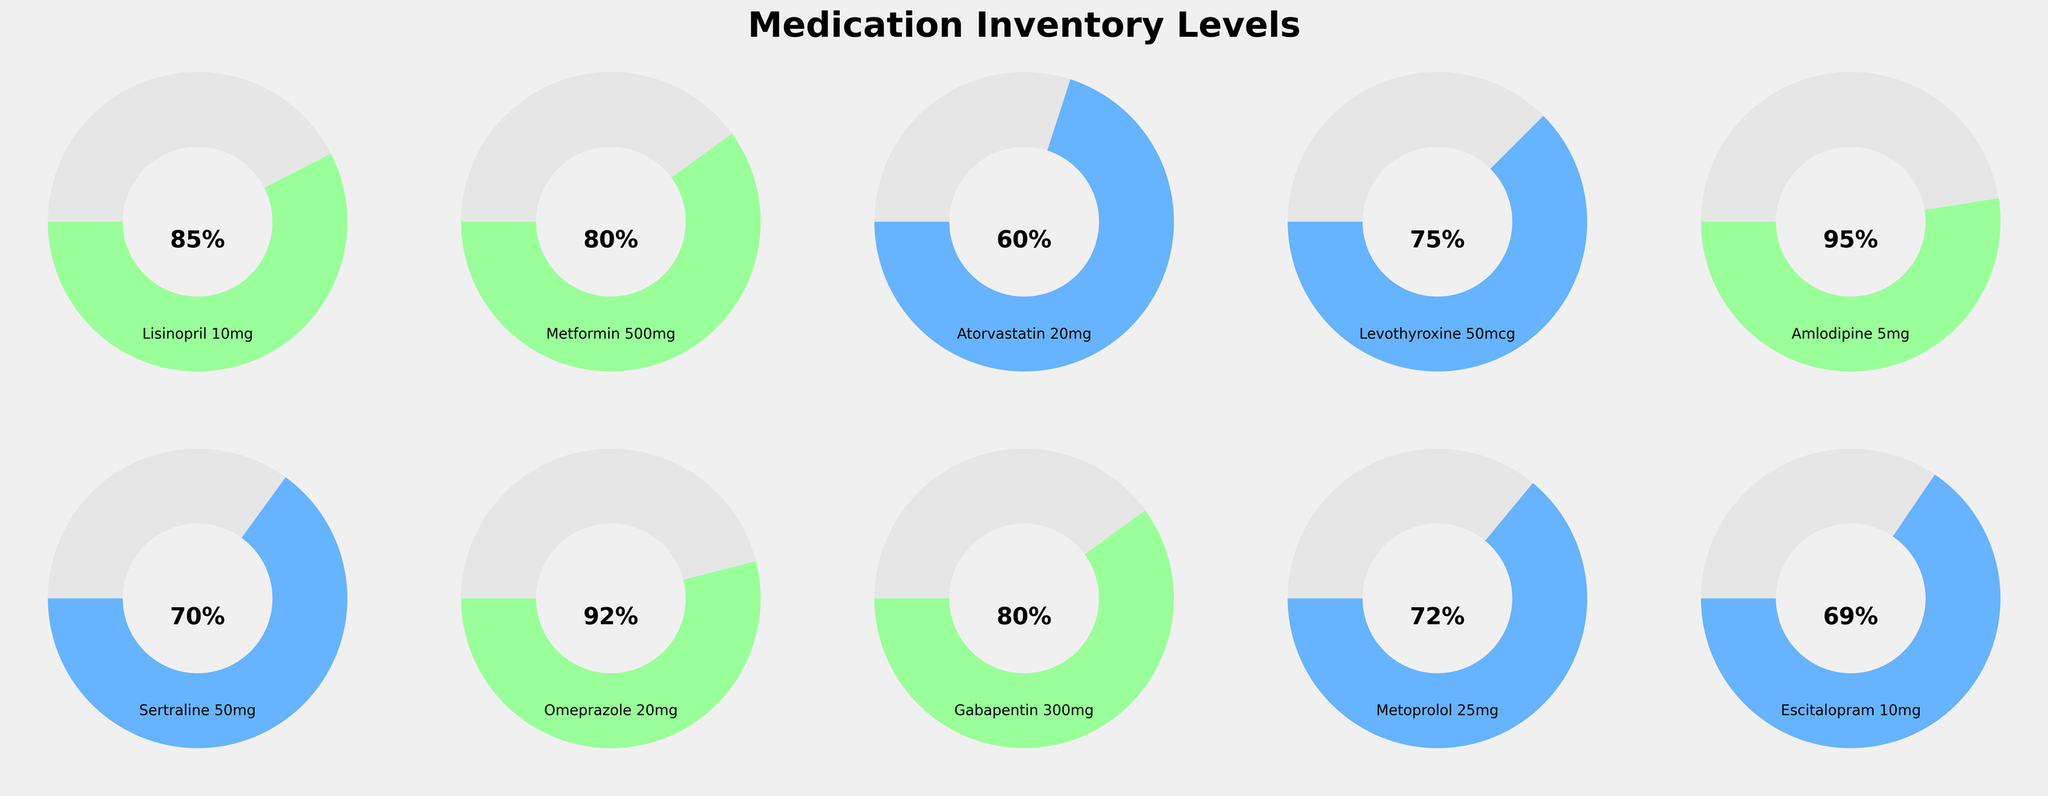Which medication has the highest inventory percentage compared to its par level? To determine which medication has the highest inventory percentage, we look at all the percentages shown on the gauge charts and find the maximum value. According to the figure, Amlodipine 5mg has the highest percentage at 95%.
Answer: Amlodipine 5mg Name two medications that have inventory levels at exactly 80%. To find the medications with an inventory level of 80%, we read the percentages on the gauge charts. The medications with 80% are Metformin 500mg and Gabapentin 300mg.
Answer: Metformin 500mg and Gabapentin 300mg What is the average inventory percentage of Lisinopril 10mg, Atorvastatin 20mg, and Levothyroxine 50mcg? To compute the average percentage, add up the percentages of Lisinopril 10mg (85%), Atorvastatin 20mg (60%), and Levothyroxine 50mcg (75%), then divide by 3. The calculation is (85 + 60 + 75) / 3 = 73.33%.
Answer: 73.33% Which medication has a lower inventory percentage: Metoprolol 25mg or Escitalopram 10mg? To determine which medication has a lower inventory percentage, compare the percentages for Metoprolol 25mg (72%) and Escitalopram 10mg (69%). Escitalopram 10mg has a lower percentage.
Answer: Escitalopram 10mg What is the total number of medications with inventory levels below 70%? To find the total number of medications with inventory levels below 70%, count all the gauge charts with percentages under 70%. According to the figure, the medications below 70% are Atorvastatin 20mg (60%) and Escitalopram 10mg (69%). Therefore, there are 2 medications.
Answer: 2 Which medication lies between 70% and 75% inventory level? To find the medication within the 70%-75% range, check the percentages and identify those that fall in this range. The medications are Sertraline 50mg (70%), Metoprolol 25mg (72%), and Levothyroxine 50mcg (75%).
Answer: Sertraline 50mg, Metoprolol 25mg, and Levothyroxine 50mcg How many medications have an inventory percentage equal to or above 90%? To find the number of medications with percentages equal to or above 90%, count the gauge charts with figures in this range: Amlodipine 5mg (95%) and Omeprazole 20mg (92%) meet this criterion. Therefore, there are 2 medications.
Answer: 2 Which medications have a lower inventory percentage than Lisinopril 10mg? To find medications with a lower inventory percentage than Lisinopril 10mg (85%), compare it to the other percentages: Atorvastatin 20mg (60%), Metformin 500mg (80%), Levothyroxine 50mcg (75%), Sertraline 50mg (70%), Metoprolol 25mg (72%), Gabapentin 300mg (80%), Escitalopram 10mg (69%). These all have lower percentages.
Answer: Metformin 500mg, Atorvastatin 20mg, Levothyroxine 50mcg, Sertraline 50mg, Metoprolol 25mg, Gabapentin 300mg, Escitalopram 10mg 